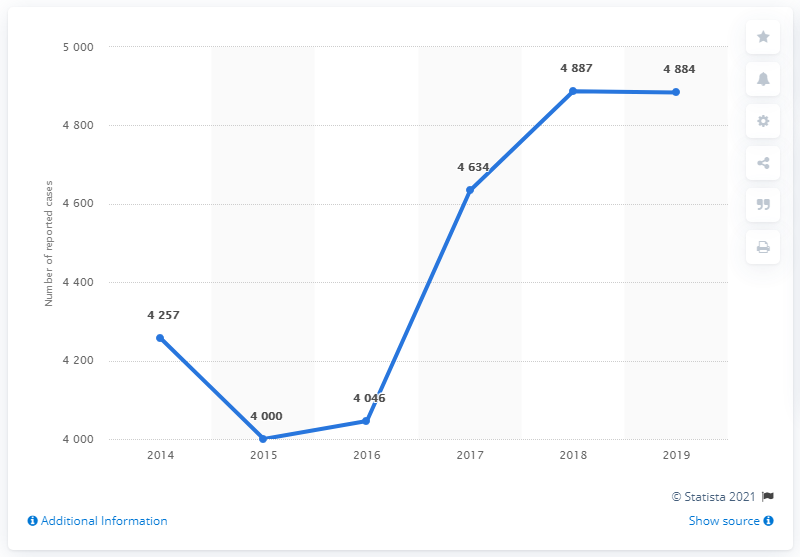Point out several critical features in this image. The median value of a graph from 2014 to 2016 is 4046. In 2015, the number of reported sexual violence cases was the lowest on record. 